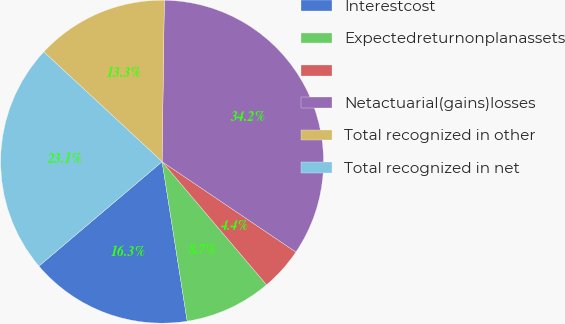Convert chart to OTSL. <chart><loc_0><loc_0><loc_500><loc_500><pie_chart><fcel>Interestcost<fcel>Expectedreturnonplanassets<fcel>Unnamed: 2<fcel>Netactuarial(gains)losses<fcel>Total recognized in other<fcel>Total recognized in net<nl><fcel>16.29%<fcel>8.71%<fcel>4.35%<fcel>34.23%<fcel>13.31%<fcel>23.1%<nl></chart> 